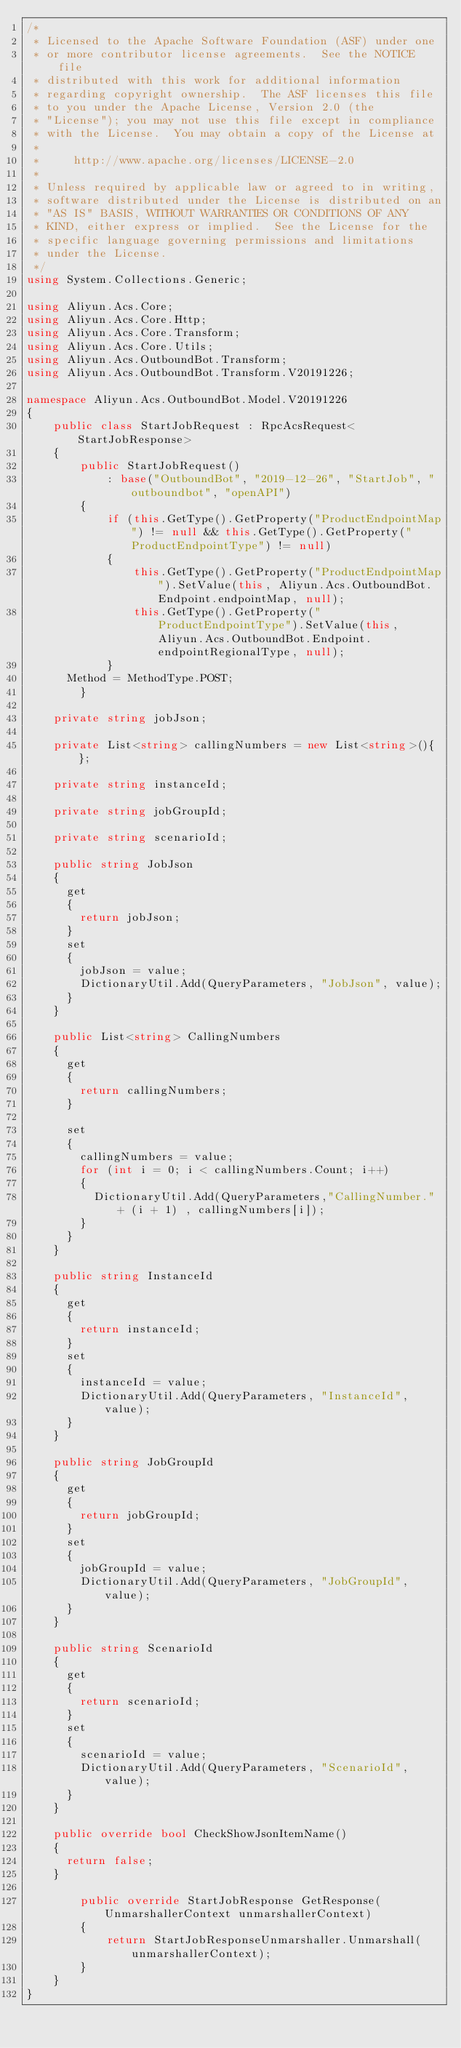<code> <loc_0><loc_0><loc_500><loc_500><_C#_>/*
 * Licensed to the Apache Software Foundation (ASF) under one
 * or more contributor license agreements.  See the NOTICE file
 * distributed with this work for additional information
 * regarding copyright ownership.  The ASF licenses this file
 * to you under the Apache License, Version 2.0 (the
 * "License"); you may not use this file except in compliance
 * with the License.  You may obtain a copy of the License at
 *
 *     http://www.apache.org/licenses/LICENSE-2.0
 *
 * Unless required by applicable law or agreed to in writing,
 * software distributed under the License is distributed on an
 * "AS IS" BASIS, WITHOUT WARRANTIES OR CONDITIONS OF ANY
 * KIND, either express or implied.  See the License for the
 * specific language governing permissions and limitations
 * under the License.
 */
using System.Collections.Generic;

using Aliyun.Acs.Core;
using Aliyun.Acs.Core.Http;
using Aliyun.Acs.Core.Transform;
using Aliyun.Acs.Core.Utils;
using Aliyun.Acs.OutboundBot.Transform;
using Aliyun.Acs.OutboundBot.Transform.V20191226;

namespace Aliyun.Acs.OutboundBot.Model.V20191226
{
    public class StartJobRequest : RpcAcsRequest<StartJobResponse>
    {
        public StartJobRequest()
            : base("OutboundBot", "2019-12-26", "StartJob", "outboundbot", "openAPI")
        {
            if (this.GetType().GetProperty("ProductEndpointMap") != null && this.GetType().GetProperty("ProductEndpointType") != null)
            {
                this.GetType().GetProperty("ProductEndpointMap").SetValue(this, Aliyun.Acs.OutboundBot.Endpoint.endpointMap, null);
                this.GetType().GetProperty("ProductEndpointType").SetValue(this, Aliyun.Acs.OutboundBot.Endpoint.endpointRegionalType, null);
            }
			Method = MethodType.POST;
        }

		private string jobJson;

		private List<string> callingNumbers = new List<string>(){ };

		private string instanceId;

		private string jobGroupId;

		private string scenarioId;

		public string JobJson
		{
			get
			{
				return jobJson;
			}
			set	
			{
				jobJson = value;
				DictionaryUtil.Add(QueryParameters, "JobJson", value);
			}
		}

		public List<string> CallingNumbers
		{
			get
			{
				return callingNumbers;
			}

			set
			{
				callingNumbers = value;
				for (int i = 0; i < callingNumbers.Count; i++)
				{
					DictionaryUtil.Add(QueryParameters,"CallingNumber." + (i + 1) , callingNumbers[i]);
				}
			}
		}

		public string InstanceId
		{
			get
			{
				return instanceId;
			}
			set	
			{
				instanceId = value;
				DictionaryUtil.Add(QueryParameters, "InstanceId", value);
			}
		}

		public string JobGroupId
		{
			get
			{
				return jobGroupId;
			}
			set	
			{
				jobGroupId = value;
				DictionaryUtil.Add(QueryParameters, "JobGroupId", value);
			}
		}

		public string ScenarioId
		{
			get
			{
				return scenarioId;
			}
			set	
			{
				scenarioId = value;
				DictionaryUtil.Add(QueryParameters, "ScenarioId", value);
			}
		}

		public override bool CheckShowJsonItemName()
		{
			return false;
		}

        public override StartJobResponse GetResponse(UnmarshallerContext unmarshallerContext)
        {
            return StartJobResponseUnmarshaller.Unmarshall(unmarshallerContext);
        }
    }
}
</code> 